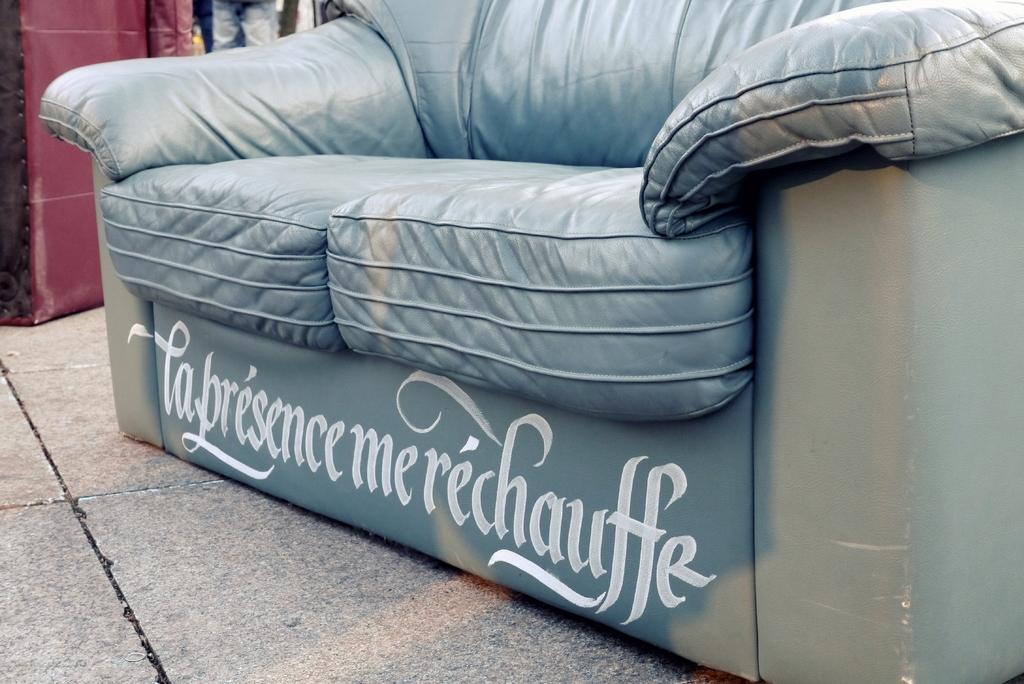What type of furniture is in the image? There is a big sofa in the image. Is there any text on the sofa? Yes, the sofa has text on it. What can be found on the surface of the sofa? There are objects on the surface of the sofa. How many horses are present on the sofa in the image? There are no horses present on the sofa in the image. What type of peace can be found on the sofa in the image? There is no peace present on the sofa in the image; it is an inanimate object. 